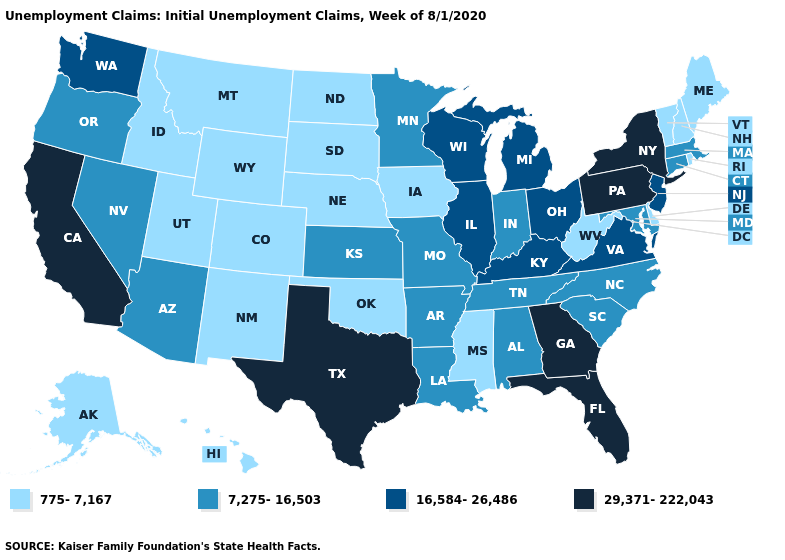Name the states that have a value in the range 16,584-26,486?
Give a very brief answer. Illinois, Kentucky, Michigan, New Jersey, Ohio, Virginia, Washington, Wisconsin. Among the states that border West Virginia , does Ohio have the lowest value?
Give a very brief answer. No. What is the value of Kansas?
Short answer required. 7,275-16,503. Which states have the lowest value in the USA?
Keep it brief. Alaska, Colorado, Delaware, Hawaii, Idaho, Iowa, Maine, Mississippi, Montana, Nebraska, New Hampshire, New Mexico, North Dakota, Oklahoma, Rhode Island, South Dakota, Utah, Vermont, West Virginia, Wyoming. Does Arizona have the lowest value in the West?
Write a very short answer. No. Among the states that border Colorado , which have the lowest value?
Answer briefly. Nebraska, New Mexico, Oklahoma, Utah, Wyoming. What is the value of Montana?
Write a very short answer. 775-7,167. Among the states that border North Dakota , does South Dakota have the highest value?
Be succinct. No. What is the highest value in the USA?
Be succinct. 29,371-222,043. What is the value of Nebraska?
Answer briefly. 775-7,167. Is the legend a continuous bar?
Quick response, please. No. Which states have the highest value in the USA?
Be succinct. California, Florida, Georgia, New York, Pennsylvania, Texas. Name the states that have a value in the range 16,584-26,486?
Short answer required. Illinois, Kentucky, Michigan, New Jersey, Ohio, Virginia, Washington, Wisconsin. Does Vermont have a lower value than South Dakota?
Write a very short answer. No. Does Montana have the lowest value in the USA?
Answer briefly. Yes. 